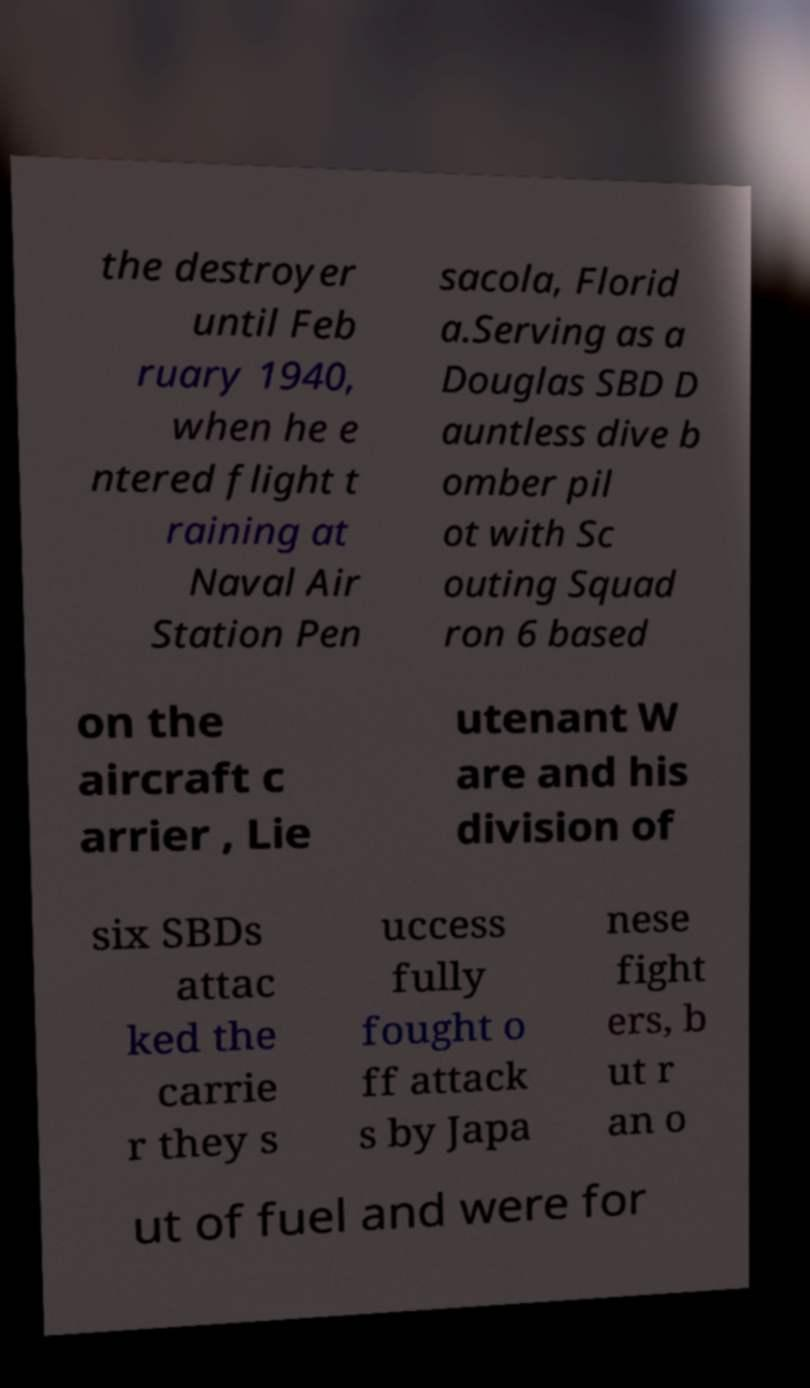Can you read and provide the text displayed in the image?This photo seems to have some interesting text. Can you extract and type it out for me? the destroyer until Feb ruary 1940, when he e ntered flight t raining at Naval Air Station Pen sacola, Florid a.Serving as a Douglas SBD D auntless dive b omber pil ot with Sc outing Squad ron 6 based on the aircraft c arrier , Lie utenant W are and his division of six SBDs attac ked the carrie r they s uccess fully fought o ff attack s by Japa nese fight ers, b ut r an o ut of fuel and were for 